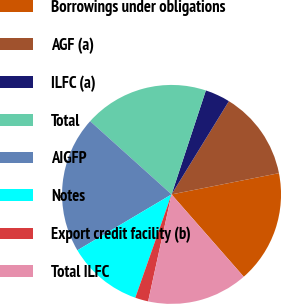<chart> <loc_0><loc_0><loc_500><loc_500><pie_chart><fcel>Borrowings under obligations<fcel>AGF (a)<fcel>ILFC (a)<fcel>Total<fcel>AIGFP<fcel>Notes<fcel>Export credit facility (b)<fcel>Total ILFC<nl><fcel>16.65%<fcel>13.12%<fcel>3.7%<fcel>18.42%<fcel>20.18%<fcel>11.11%<fcel>1.94%<fcel>14.89%<nl></chart> 